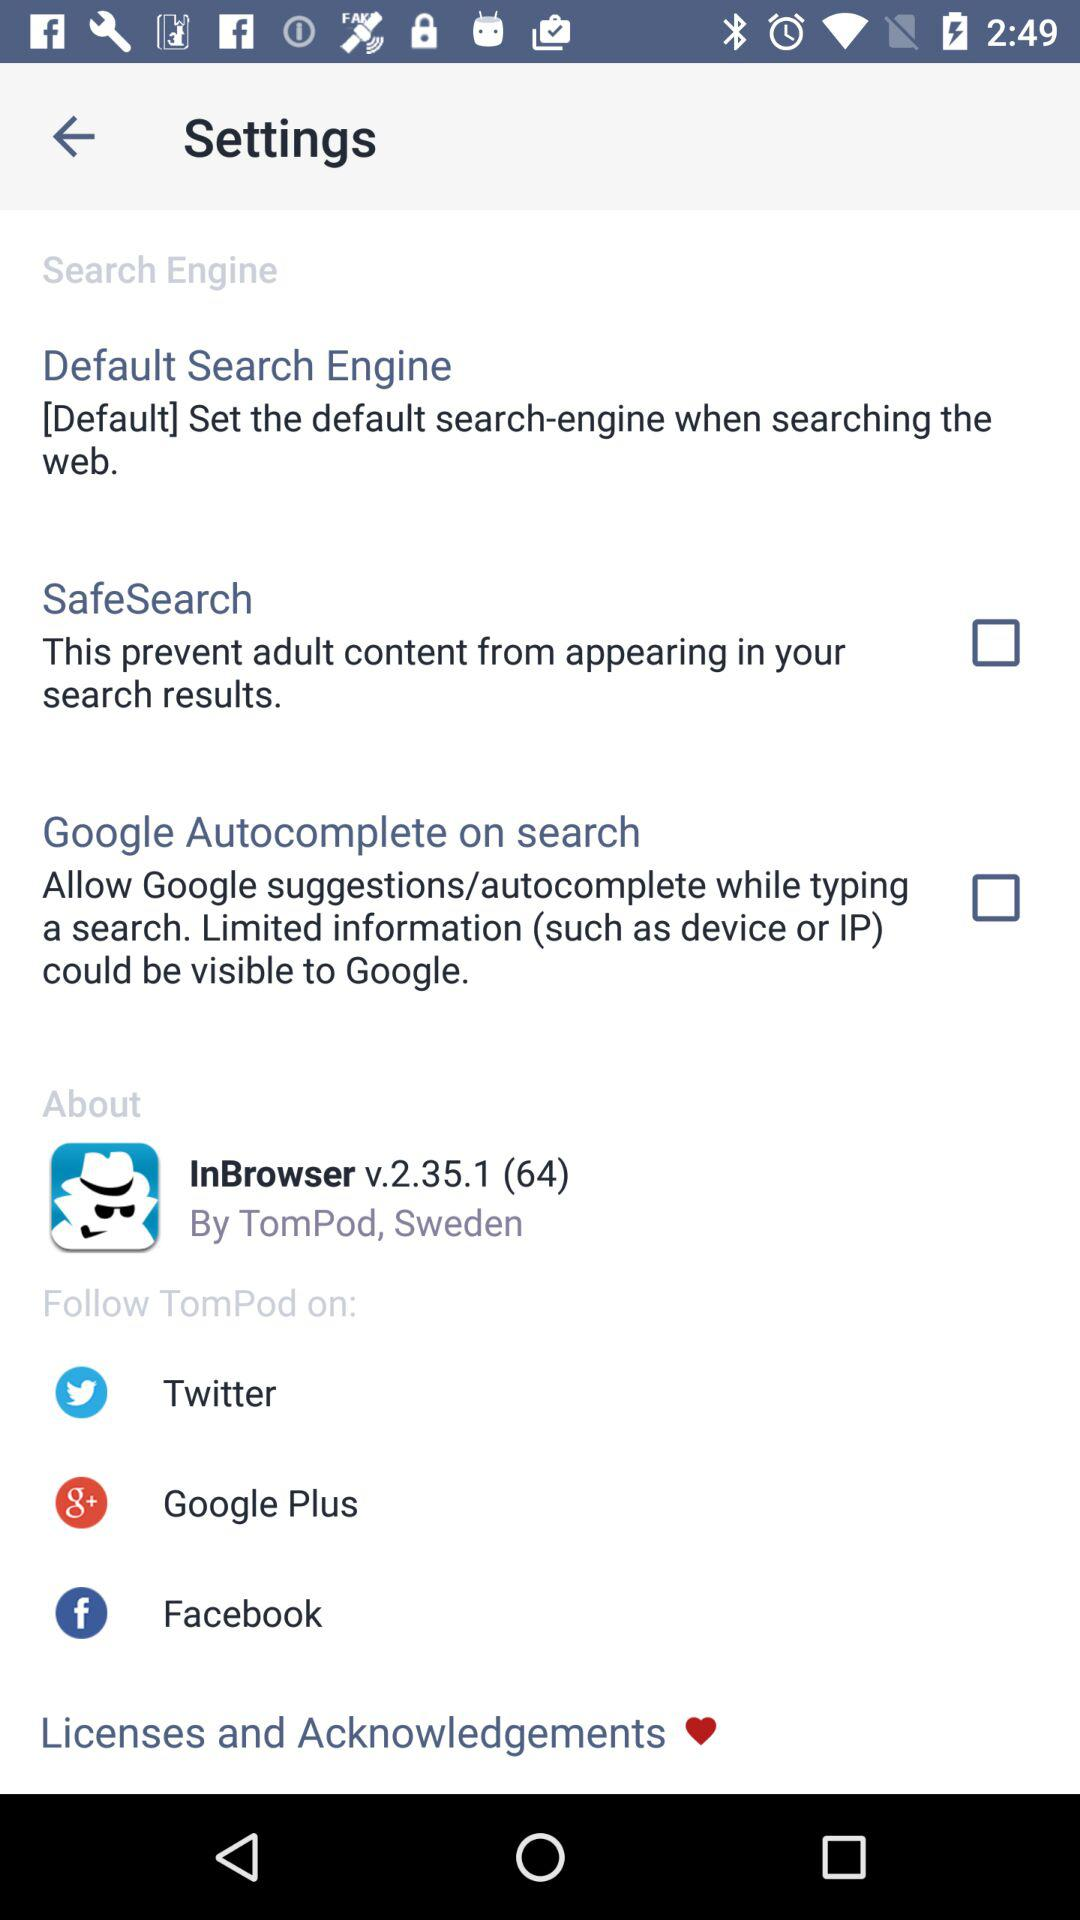Which social platforms can "TomPod" be followed on? "TomPod" can be followed on "Twitter", "Google Plus" and "Facebook". 